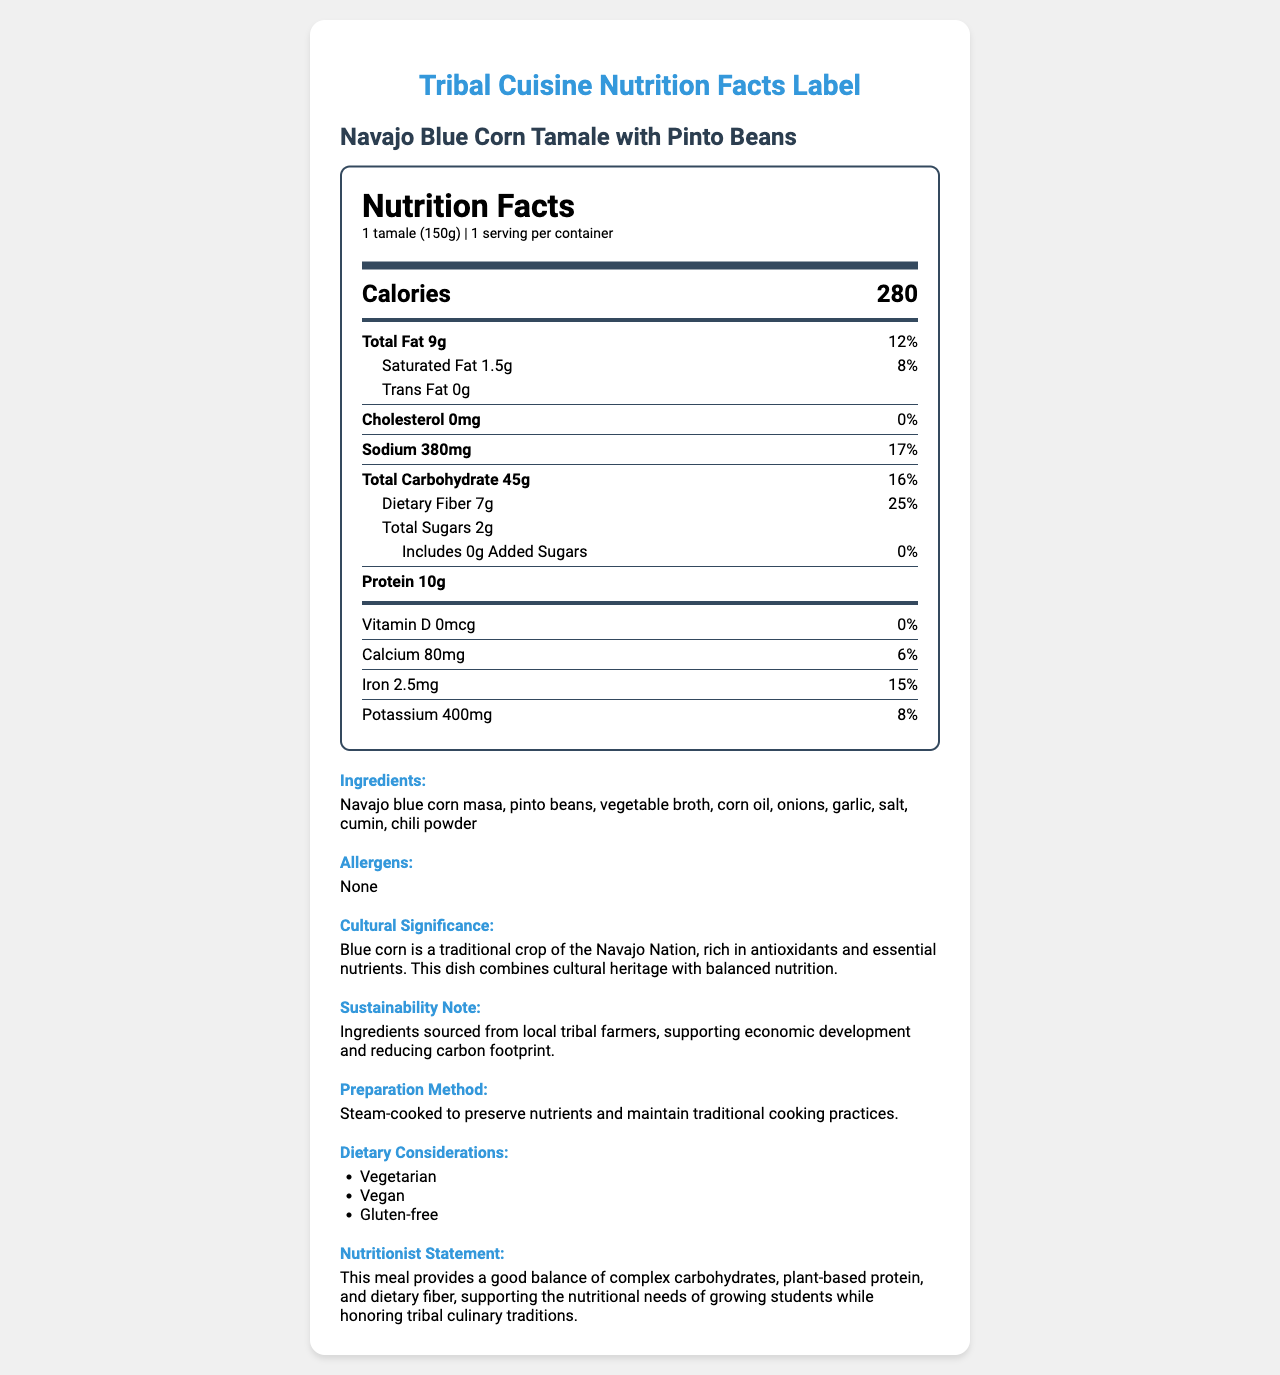what is the serving size of the Navajo Blue Corn Tamale with Pinto Beans? The serving size is mentioned as "1 tamale (150g)" in the document.
Answer: 1 tamale (150g) how many calories are in one serving? The document states that there are 280 calories per serving.
Answer: 280 what is the total fat content in one serving? According to the document, the total fat content is 9g.
Answer: 9g how much dietary fiber does one serving contain? The document lists the dietary fiber content as 7g.
Answer: 7g does the product contain any added sugars? The label indicates that there are 0g of added sugars.
Answer: 0g D. Red beans The ingredient list includes "pinto beans" but not chicken broth, wheat flour, or red beans.
Answer: B. Pinto beans what is the daily value percentage of Sodium in one serving? The document shows the daily value percentage of Sodium as 17%.
Answer: 17% D. Potassium The document lists Protein, Iron, and Potassium, but does not mention Vitamin C.
Answer: B. Vitamin C is this product vegetarian? The dietary considerations section labels the product as "Vegetarian".
Answer: Yes summarize the document. The document covers multiple aspects including nutrition facts per serving, confirming the product's health benefits and cultural value. It emphasizes sustainability and dietary considerations, ensuring it meets various dietary needs.
Answer: The document provides detailed nutrition facts, ingredient list, allergens, cultural significance, sustainability notes, preparation method, dietary considerations, and a nutritionist statement for the Navajo Blue Corn Tamale with Pinto Beans. It highlights that the meal is nutritious and honors tribal culinary traditions while being supportive of local farmers. what is the carbon footprint of the ingredients used in the product? The document doesn't provide specific data about the carbon footprint of the ingredients.
Answer: Not enough information which nutrient has the highest daily value percentage? The document shows the daily value percentage for dietary fiber as 25%, which is the highest among the listed nutrients.
Answer: Dietary Fiber with 25% 